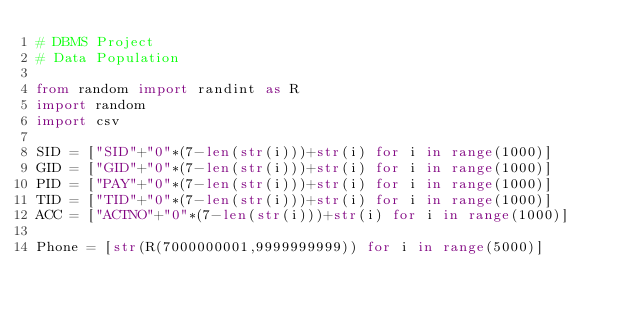<code> <loc_0><loc_0><loc_500><loc_500><_Python_># DBMS Project
# Data Population

from random import randint as R
import random
import csv

SID = ["SID"+"0"*(7-len(str(i)))+str(i) for i in range(1000)]
GID = ["GID"+"0"*(7-len(str(i)))+str(i) for i in range(1000)]
PID = ["PAY"+"0"*(7-len(str(i)))+str(i) for i in range(1000)]
TID = ["TID"+"0"*(7-len(str(i)))+str(i) for i in range(1000)]
ACC = ["ACTNO"+"0"*(7-len(str(i)))+str(i) for i in range(1000)]

Phone = [str(R(7000000001,9999999999)) for i in range(5000)]

</code> 